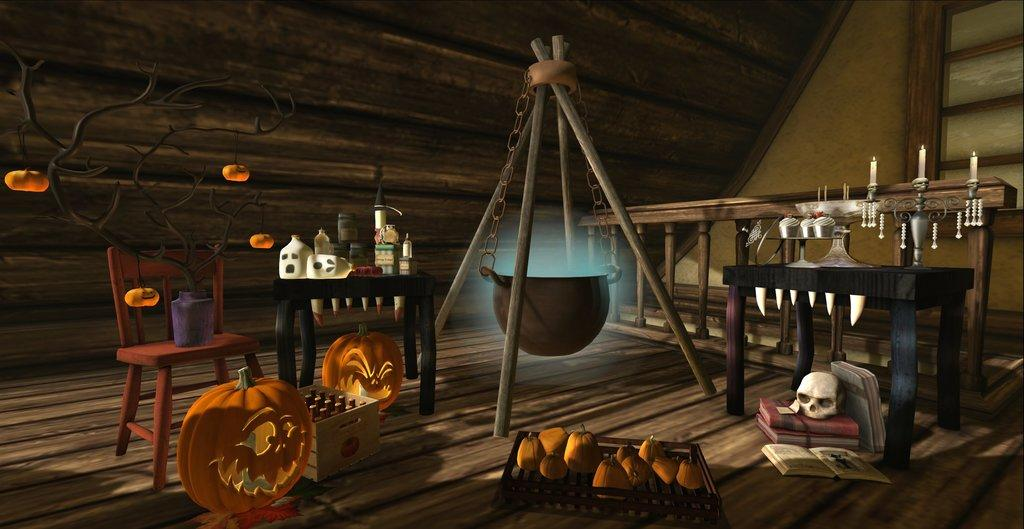What type of furniture is present in the image? There is a chair and a table in the image. What items can be found on the table? Books and candles are present on the table in the image. What is the top of in the image? There is a top in the image, which might refer to a spinning top toy. What is the chain attached to in the image? The chain is attached to the top in the image. What type of food items are visible in the image? There are vegetables in the image. What type of flooring is present in the image? There is a wooden floor in the image. What time of day does the image depict, and how does the regret manifest in the scene? The image does not depict a specific time of day, and there is no indication of regret in the scene. 